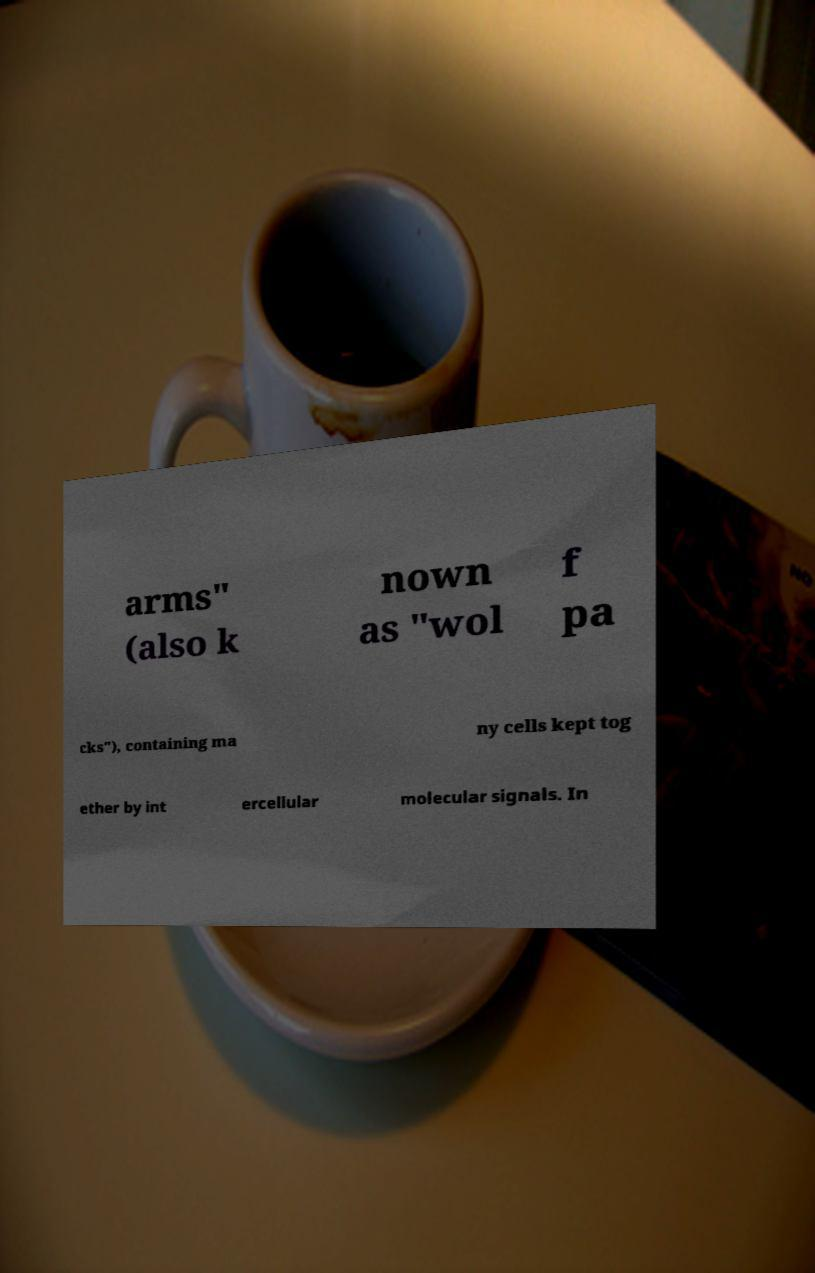There's text embedded in this image that I need extracted. Can you transcribe it verbatim? arms" (also k nown as "wol f pa cks"), containing ma ny cells kept tog ether by int ercellular molecular signals. In 